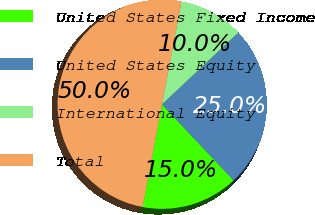Convert chart. <chart><loc_0><loc_0><loc_500><loc_500><pie_chart><fcel>United States Fixed Income<fcel>United States Equity<fcel>International Equity<fcel>Total<nl><fcel>15.0%<fcel>25.0%<fcel>10.0%<fcel>50.0%<nl></chart> 